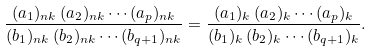Convert formula to latex. <formula><loc_0><loc_0><loc_500><loc_500>\frac { ( a _ { 1 } ) _ { n k } \, ( a _ { 2 } ) _ { n k } \cdots ( a _ { p } ) _ { n k } } { ( b _ { 1 } ) _ { n k } \, ( b _ { 2 } ) _ { n k } \cdots ( b _ { q + 1 } ) _ { n k } } = \frac { ( a _ { 1 } ) _ { k } \, ( a _ { 2 } ) _ { k } \cdots ( a _ { p } ) _ { k } } { ( b _ { 1 } ) _ { k } \, ( b _ { 2 } ) _ { k } \cdots ( b _ { q + 1 } ) _ { k } } .</formula> 